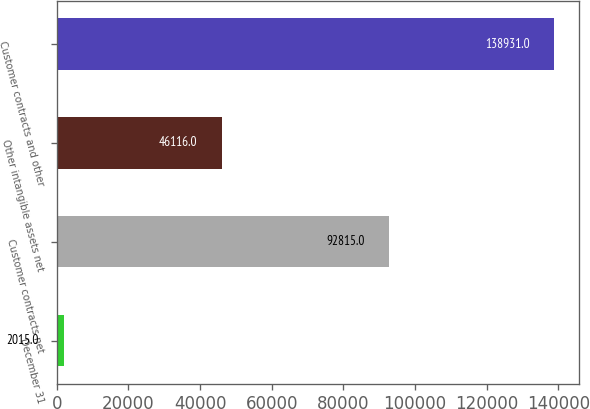Convert chart. <chart><loc_0><loc_0><loc_500><loc_500><bar_chart><fcel>December 31<fcel>Customer contracts net<fcel>Other intangible assets net<fcel>Customer contracts and other<nl><fcel>2015<fcel>92815<fcel>46116<fcel>138931<nl></chart> 